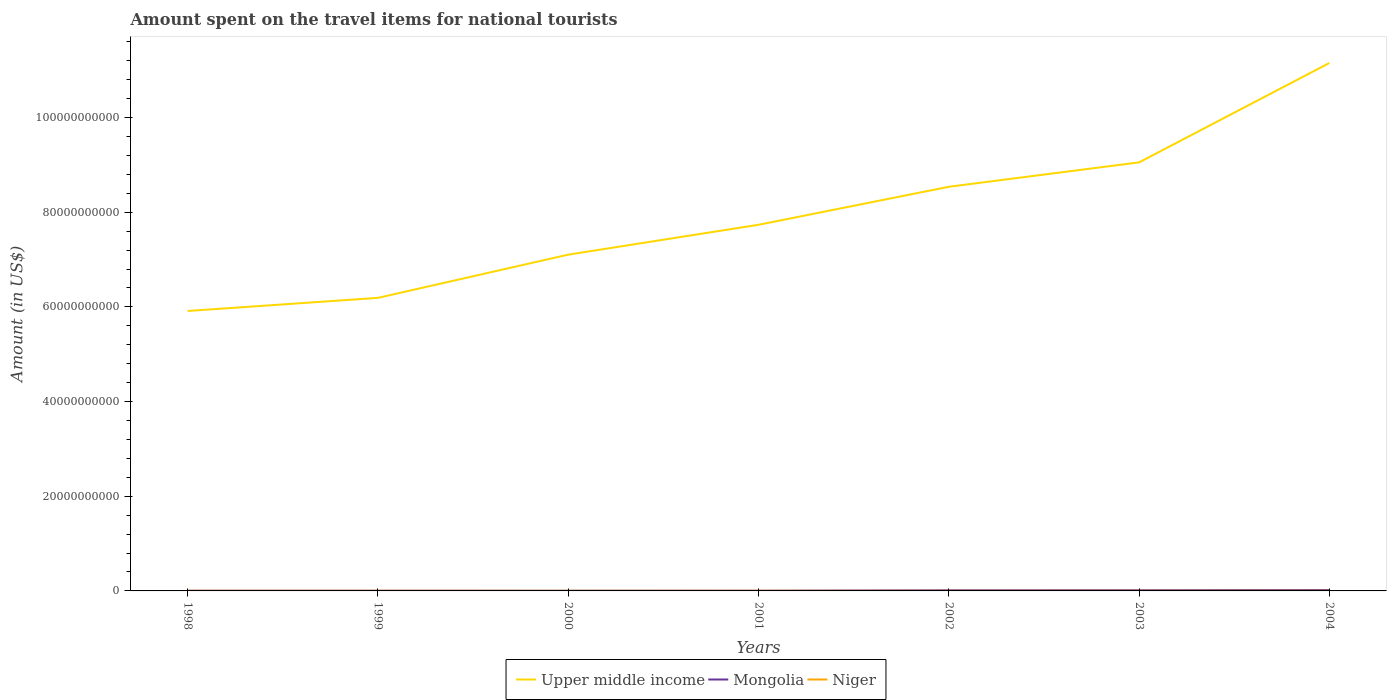How many different coloured lines are there?
Provide a succinct answer. 3. Across all years, what is the maximum amount spent on the travel items for national tourists in Niger?
Ensure brevity in your answer.  2.00e+07. In which year was the amount spent on the travel items for national tourists in Niger maximum?
Keep it short and to the point. 2002. What is the total amount spent on the travel items for national tourists in Mongolia in the graph?
Your response must be concise. -9.50e+07. What is the difference between the highest and the second highest amount spent on the travel items for national tourists in Niger?
Provide a short and direct response. 1.10e+07. Is the amount spent on the travel items for national tourists in Mongolia strictly greater than the amount spent on the travel items for national tourists in Upper middle income over the years?
Your answer should be compact. Yes. What is the difference between two consecutive major ticks on the Y-axis?
Ensure brevity in your answer.  2.00e+1. Does the graph contain grids?
Provide a short and direct response. No. What is the title of the graph?
Offer a terse response. Amount spent on the travel items for national tourists. Does "Ghana" appear as one of the legend labels in the graph?
Make the answer very short. No. What is the Amount (in US$) of Upper middle income in 1998?
Offer a very short reply. 5.91e+1. What is the Amount (in US$) in Mongolia in 1998?
Provide a succinct answer. 3.50e+07. What is the Amount (in US$) in Niger in 1998?
Ensure brevity in your answer.  2.70e+07. What is the Amount (in US$) in Upper middle income in 1999?
Ensure brevity in your answer.  6.19e+1. What is the Amount (in US$) of Mongolia in 1999?
Provide a succinct answer. 3.60e+07. What is the Amount (in US$) of Niger in 1999?
Your answer should be very brief. 2.50e+07. What is the Amount (in US$) of Upper middle income in 2000?
Offer a very short reply. 7.10e+1. What is the Amount (in US$) of Mongolia in 2000?
Give a very brief answer. 3.60e+07. What is the Amount (in US$) of Niger in 2000?
Make the answer very short. 2.30e+07. What is the Amount (in US$) in Upper middle income in 2001?
Give a very brief answer. 7.74e+1. What is the Amount (in US$) of Mongolia in 2001?
Offer a terse response. 3.90e+07. What is the Amount (in US$) in Niger in 2001?
Your response must be concise. 3.00e+07. What is the Amount (in US$) in Upper middle income in 2002?
Ensure brevity in your answer.  8.54e+1. What is the Amount (in US$) of Mongolia in 2002?
Give a very brief answer. 1.30e+08. What is the Amount (in US$) in Upper middle income in 2003?
Offer a very short reply. 9.05e+1. What is the Amount (in US$) in Mongolia in 2003?
Keep it short and to the point. 1.43e+08. What is the Amount (in US$) of Niger in 2003?
Offer a terse response. 2.70e+07. What is the Amount (in US$) in Upper middle income in 2004?
Offer a terse response. 1.12e+11. What is the Amount (in US$) of Mongolia in 2004?
Offer a very short reply. 1.85e+08. What is the Amount (in US$) of Niger in 2004?
Offer a terse response. 3.10e+07. Across all years, what is the maximum Amount (in US$) of Upper middle income?
Your response must be concise. 1.12e+11. Across all years, what is the maximum Amount (in US$) in Mongolia?
Give a very brief answer. 1.85e+08. Across all years, what is the maximum Amount (in US$) in Niger?
Keep it short and to the point. 3.10e+07. Across all years, what is the minimum Amount (in US$) in Upper middle income?
Give a very brief answer. 5.91e+1. Across all years, what is the minimum Amount (in US$) of Mongolia?
Your answer should be very brief. 3.50e+07. What is the total Amount (in US$) of Upper middle income in the graph?
Ensure brevity in your answer.  5.57e+11. What is the total Amount (in US$) of Mongolia in the graph?
Ensure brevity in your answer.  6.04e+08. What is the total Amount (in US$) in Niger in the graph?
Give a very brief answer. 1.83e+08. What is the difference between the Amount (in US$) in Upper middle income in 1998 and that in 1999?
Provide a succinct answer. -2.77e+09. What is the difference between the Amount (in US$) of Mongolia in 1998 and that in 1999?
Provide a short and direct response. -1.00e+06. What is the difference between the Amount (in US$) in Niger in 1998 and that in 1999?
Ensure brevity in your answer.  2.00e+06. What is the difference between the Amount (in US$) in Upper middle income in 1998 and that in 2000?
Offer a very short reply. -1.19e+1. What is the difference between the Amount (in US$) in Mongolia in 1998 and that in 2000?
Your answer should be compact. -1.00e+06. What is the difference between the Amount (in US$) in Niger in 1998 and that in 2000?
Offer a terse response. 4.00e+06. What is the difference between the Amount (in US$) in Upper middle income in 1998 and that in 2001?
Ensure brevity in your answer.  -1.82e+1. What is the difference between the Amount (in US$) of Niger in 1998 and that in 2001?
Ensure brevity in your answer.  -3.00e+06. What is the difference between the Amount (in US$) of Upper middle income in 1998 and that in 2002?
Keep it short and to the point. -2.62e+1. What is the difference between the Amount (in US$) of Mongolia in 1998 and that in 2002?
Offer a terse response. -9.50e+07. What is the difference between the Amount (in US$) of Upper middle income in 1998 and that in 2003?
Keep it short and to the point. -3.14e+1. What is the difference between the Amount (in US$) in Mongolia in 1998 and that in 2003?
Make the answer very short. -1.08e+08. What is the difference between the Amount (in US$) of Upper middle income in 1998 and that in 2004?
Keep it short and to the point. -5.24e+1. What is the difference between the Amount (in US$) in Mongolia in 1998 and that in 2004?
Your answer should be very brief. -1.50e+08. What is the difference between the Amount (in US$) in Niger in 1998 and that in 2004?
Provide a succinct answer. -4.00e+06. What is the difference between the Amount (in US$) in Upper middle income in 1999 and that in 2000?
Provide a short and direct response. -9.13e+09. What is the difference between the Amount (in US$) of Niger in 1999 and that in 2000?
Give a very brief answer. 2.00e+06. What is the difference between the Amount (in US$) of Upper middle income in 1999 and that in 2001?
Offer a very short reply. -1.54e+1. What is the difference between the Amount (in US$) in Niger in 1999 and that in 2001?
Keep it short and to the point. -5.00e+06. What is the difference between the Amount (in US$) in Upper middle income in 1999 and that in 2002?
Make the answer very short. -2.35e+1. What is the difference between the Amount (in US$) of Mongolia in 1999 and that in 2002?
Provide a short and direct response. -9.40e+07. What is the difference between the Amount (in US$) of Niger in 1999 and that in 2002?
Your answer should be very brief. 5.00e+06. What is the difference between the Amount (in US$) of Upper middle income in 1999 and that in 2003?
Offer a very short reply. -2.86e+1. What is the difference between the Amount (in US$) of Mongolia in 1999 and that in 2003?
Give a very brief answer. -1.07e+08. What is the difference between the Amount (in US$) in Upper middle income in 1999 and that in 2004?
Your answer should be compact. -4.96e+1. What is the difference between the Amount (in US$) of Mongolia in 1999 and that in 2004?
Give a very brief answer. -1.49e+08. What is the difference between the Amount (in US$) in Niger in 1999 and that in 2004?
Keep it short and to the point. -6.00e+06. What is the difference between the Amount (in US$) in Upper middle income in 2000 and that in 2001?
Ensure brevity in your answer.  -6.31e+09. What is the difference between the Amount (in US$) in Mongolia in 2000 and that in 2001?
Your answer should be compact. -3.00e+06. What is the difference between the Amount (in US$) of Niger in 2000 and that in 2001?
Offer a very short reply. -7.00e+06. What is the difference between the Amount (in US$) of Upper middle income in 2000 and that in 2002?
Give a very brief answer. -1.43e+1. What is the difference between the Amount (in US$) of Mongolia in 2000 and that in 2002?
Offer a terse response. -9.40e+07. What is the difference between the Amount (in US$) of Upper middle income in 2000 and that in 2003?
Give a very brief answer. -1.95e+1. What is the difference between the Amount (in US$) in Mongolia in 2000 and that in 2003?
Offer a terse response. -1.07e+08. What is the difference between the Amount (in US$) of Niger in 2000 and that in 2003?
Your answer should be compact. -4.00e+06. What is the difference between the Amount (in US$) in Upper middle income in 2000 and that in 2004?
Keep it short and to the point. -4.05e+1. What is the difference between the Amount (in US$) in Mongolia in 2000 and that in 2004?
Your answer should be very brief. -1.49e+08. What is the difference between the Amount (in US$) in Niger in 2000 and that in 2004?
Offer a terse response. -8.00e+06. What is the difference between the Amount (in US$) in Upper middle income in 2001 and that in 2002?
Offer a very short reply. -8.03e+09. What is the difference between the Amount (in US$) in Mongolia in 2001 and that in 2002?
Your response must be concise. -9.10e+07. What is the difference between the Amount (in US$) of Upper middle income in 2001 and that in 2003?
Offer a very short reply. -1.32e+1. What is the difference between the Amount (in US$) in Mongolia in 2001 and that in 2003?
Provide a succinct answer. -1.04e+08. What is the difference between the Amount (in US$) of Niger in 2001 and that in 2003?
Provide a succinct answer. 3.00e+06. What is the difference between the Amount (in US$) of Upper middle income in 2001 and that in 2004?
Ensure brevity in your answer.  -3.42e+1. What is the difference between the Amount (in US$) in Mongolia in 2001 and that in 2004?
Offer a very short reply. -1.46e+08. What is the difference between the Amount (in US$) in Upper middle income in 2002 and that in 2003?
Offer a very short reply. -5.16e+09. What is the difference between the Amount (in US$) in Mongolia in 2002 and that in 2003?
Offer a very short reply. -1.30e+07. What is the difference between the Amount (in US$) in Niger in 2002 and that in 2003?
Offer a terse response. -7.00e+06. What is the difference between the Amount (in US$) in Upper middle income in 2002 and that in 2004?
Provide a succinct answer. -2.62e+1. What is the difference between the Amount (in US$) in Mongolia in 2002 and that in 2004?
Offer a terse response. -5.50e+07. What is the difference between the Amount (in US$) in Niger in 2002 and that in 2004?
Your response must be concise. -1.10e+07. What is the difference between the Amount (in US$) of Upper middle income in 2003 and that in 2004?
Provide a short and direct response. -2.10e+1. What is the difference between the Amount (in US$) in Mongolia in 2003 and that in 2004?
Provide a succinct answer. -4.20e+07. What is the difference between the Amount (in US$) of Niger in 2003 and that in 2004?
Provide a short and direct response. -4.00e+06. What is the difference between the Amount (in US$) in Upper middle income in 1998 and the Amount (in US$) in Mongolia in 1999?
Provide a succinct answer. 5.91e+1. What is the difference between the Amount (in US$) of Upper middle income in 1998 and the Amount (in US$) of Niger in 1999?
Provide a short and direct response. 5.91e+1. What is the difference between the Amount (in US$) in Upper middle income in 1998 and the Amount (in US$) in Mongolia in 2000?
Offer a very short reply. 5.91e+1. What is the difference between the Amount (in US$) in Upper middle income in 1998 and the Amount (in US$) in Niger in 2000?
Give a very brief answer. 5.91e+1. What is the difference between the Amount (in US$) of Upper middle income in 1998 and the Amount (in US$) of Mongolia in 2001?
Give a very brief answer. 5.91e+1. What is the difference between the Amount (in US$) in Upper middle income in 1998 and the Amount (in US$) in Niger in 2001?
Your answer should be very brief. 5.91e+1. What is the difference between the Amount (in US$) of Upper middle income in 1998 and the Amount (in US$) of Mongolia in 2002?
Your response must be concise. 5.90e+1. What is the difference between the Amount (in US$) in Upper middle income in 1998 and the Amount (in US$) in Niger in 2002?
Your answer should be very brief. 5.91e+1. What is the difference between the Amount (in US$) of Mongolia in 1998 and the Amount (in US$) of Niger in 2002?
Your answer should be very brief. 1.50e+07. What is the difference between the Amount (in US$) of Upper middle income in 1998 and the Amount (in US$) of Mongolia in 2003?
Provide a succinct answer. 5.90e+1. What is the difference between the Amount (in US$) of Upper middle income in 1998 and the Amount (in US$) of Niger in 2003?
Give a very brief answer. 5.91e+1. What is the difference between the Amount (in US$) in Mongolia in 1998 and the Amount (in US$) in Niger in 2003?
Provide a succinct answer. 8.00e+06. What is the difference between the Amount (in US$) of Upper middle income in 1998 and the Amount (in US$) of Mongolia in 2004?
Your answer should be compact. 5.90e+1. What is the difference between the Amount (in US$) in Upper middle income in 1998 and the Amount (in US$) in Niger in 2004?
Provide a short and direct response. 5.91e+1. What is the difference between the Amount (in US$) in Mongolia in 1998 and the Amount (in US$) in Niger in 2004?
Provide a short and direct response. 4.00e+06. What is the difference between the Amount (in US$) of Upper middle income in 1999 and the Amount (in US$) of Mongolia in 2000?
Your answer should be compact. 6.19e+1. What is the difference between the Amount (in US$) in Upper middle income in 1999 and the Amount (in US$) in Niger in 2000?
Provide a succinct answer. 6.19e+1. What is the difference between the Amount (in US$) of Mongolia in 1999 and the Amount (in US$) of Niger in 2000?
Your answer should be compact. 1.30e+07. What is the difference between the Amount (in US$) of Upper middle income in 1999 and the Amount (in US$) of Mongolia in 2001?
Provide a succinct answer. 6.19e+1. What is the difference between the Amount (in US$) of Upper middle income in 1999 and the Amount (in US$) of Niger in 2001?
Ensure brevity in your answer.  6.19e+1. What is the difference between the Amount (in US$) in Upper middle income in 1999 and the Amount (in US$) in Mongolia in 2002?
Keep it short and to the point. 6.18e+1. What is the difference between the Amount (in US$) of Upper middle income in 1999 and the Amount (in US$) of Niger in 2002?
Offer a terse response. 6.19e+1. What is the difference between the Amount (in US$) in Mongolia in 1999 and the Amount (in US$) in Niger in 2002?
Offer a very short reply. 1.60e+07. What is the difference between the Amount (in US$) in Upper middle income in 1999 and the Amount (in US$) in Mongolia in 2003?
Ensure brevity in your answer.  6.18e+1. What is the difference between the Amount (in US$) of Upper middle income in 1999 and the Amount (in US$) of Niger in 2003?
Offer a terse response. 6.19e+1. What is the difference between the Amount (in US$) of Mongolia in 1999 and the Amount (in US$) of Niger in 2003?
Give a very brief answer. 9.00e+06. What is the difference between the Amount (in US$) in Upper middle income in 1999 and the Amount (in US$) in Mongolia in 2004?
Make the answer very short. 6.17e+1. What is the difference between the Amount (in US$) of Upper middle income in 1999 and the Amount (in US$) of Niger in 2004?
Offer a terse response. 6.19e+1. What is the difference between the Amount (in US$) of Upper middle income in 2000 and the Amount (in US$) of Mongolia in 2001?
Offer a very short reply. 7.10e+1. What is the difference between the Amount (in US$) of Upper middle income in 2000 and the Amount (in US$) of Niger in 2001?
Keep it short and to the point. 7.10e+1. What is the difference between the Amount (in US$) in Mongolia in 2000 and the Amount (in US$) in Niger in 2001?
Give a very brief answer. 6.00e+06. What is the difference between the Amount (in US$) in Upper middle income in 2000 and the Amount (in US$) in Mongolia in 2002?
Make the answer very short. 7.09e+1. What is the difference between the Amount (in US$) of Upper middle income in 2000 and the Amount (in US$) of Niger in 2002?
Ensure brevity in your answer.  7.10e+1. What is the difference between the Amount (in US$) of Mongolia in 2000 and the Amount (in US$) of Niger in 2002?
Make the answer very short. 1.60e+07. What is the difference between the Amount (in US$) of Upper middle income in 2000 and the Amount (in US$) of Mongolia in 2003?
Your answer should be compact. 7.09e+1. What is the difference between the Amount (in US$) in Upper middle income in 2000 and the Amount (in US$) in Niger in 2003?
Offer a very short reply. 7.10e+1. What is the difference between the Amount (in US$) in Mongolia in 2000 and the Amount (in US$) in Niger in 2003?
Provide a succinct answer. 9.00e+06. What is the difference between the Amount (in US$) of Upper middle income in 2000 and the Amount (in US$) of Mongolia in 2004?
Offer a very short reply. 7.09e+1. What is the difference between the Amount (in US$) in Upper middle income in 2000 and the Amount (in US$) in Niger in 2004?
Make the answer very short. 7.10e+1. What is the difference between the Amount (in US$) in Upper middle income in 2001 and the Amount (in US$) in Mongolia in 2002?
Ensure brevity in your answer.  7.72e+1. What is the difference between the Amount (in US$) in Upper middle income in 2001 and the Amount (in US$) in Niger in 2002?
Give a very brief answer. 7.73e+1. What is the difference between the Amount (in US$) in Mongolia in 2001 and the Amount (in US$) in Niger in 2002?
Offer a terse response. 1.90e+07. What is the difference between the Amount (in US$) of Upper middle income in 2001 and the Amount (in US$) of Mongolia in 2003?
Offer a terse response. 7.72e+1. What is the difference between the Amount (in US$) of Upper middle income in 2001 and the Amount (in US$) of Niger in 2003?
Your answer should be very brief. 7.73e+1. What is the difference between the Amount (in US$) of Upper middle income in 2001 and the Amount (in US$) of Mongolia in 2004?
Keep it short and to the point. 7.72e+1. What is the difference between the Amount (in US$) of Upper middle income in 2001 and the Amount (in US$) of Niger in 2004?
Your response must be concise. 7.73e+1. What is the difference between the Amount (in US$) of Upper middle income in 2002 and the Amount (in US$) of Mongolia in 2003?
Your response must be concise. 8.52e+1. What is the difference between the Amount (in US$) of Upper middle income in 2002 and the Amount (in US$) of Niger in 2003?
Give a very brief answer. 8.54e+1. What is the difference between the Amount (in US$) in Mongolia in 2002 and the Amount (in US$) in Niger in 2003?
Ensure brevity in your answer.  1.03e+08. What is the difference between the Amount (in US$) in Upper middle income in 2002 and the Amount (in US$) in Mongolia in 2004?
Make the answer very short. 8.52e+1. What is the difference between the Amount (in US$) of Upper middle income in 2002 and the Amount (in US$) of Niger in 2004?
Your answer should be very brief. 8.53e+1. What is the difference between the Amount (in US$) of Mongolia in 2002 and the Amount (in US$) of Niger in 2004?
Your response must be concise. 9.90e+07. What is the difference between the Amount (in US$) in Upper middle income in 2003 and the Amount (in US$) in Mongolia in 2004?
Keep it short and to the point. 9.04e+1. What is the difference between the Amount (in US$) in Upper middle income in 2003 and the Amount (in US$) in Niger in 2004?
Give a very brief answer. 9.05e+1. What is the difference between the Amount (in US$) in Mongolia in 2003 and the Amount (in US$) in Niger in 2004?
Keep it short and to the point. 1.12e+08. What is the average Amount (in US$) in Upper middle income per year?
Offer a very short reply. 7.96e+1. What is the average Amount (in US$) in Mongolia per year?
Your response must be concise. 8.63e+07. What is the average Amount (in US$) of Niger per year?
Give a very brief answer. 2.61e+07. In the year 1998, what is the difference between the Amount (in US$) in Upper middle income and Amount (in US$) in Mongolia?
Offer a terse response. 5.91e+1. In the year 1998, what is the difference between the Amount (in US$) of Upper middle income and Amount (in US$) of Niger?
Offer a very short reply. 5.91e+1. In the year 1999, what is the difference between the Amount (in US$) in Upper middle income and Amount (in US$) in Mongolia?
Ensure brevity in your answer.  6.19e+1. In the year 1999, what is the difference between the Amount (in US$) in Upper middle income and Amount (in US$) in Niger?
Offer a very short reply. 6.19e+1. In the year 1999, what is the difference between the Amount (in US$) in Mongolia and Amount (in US$) in Niger?
Provide a short and direct response. 1.10e+07. In the year 2000, what is the difference between the Amount (in US$) in Upper middle income and Amount (in US$) in Mongolia?
Provide a succinct answer. 7.10e+1. In the year 2000, what is the difference between the Amount (in US$) of Upper middle income and Amount (in US$) of Niger?
Provide a succinct answer. 7.10e+1. In the year 2000, what is the difference between the Amount (in US$) of Mongolia and Amount (in US$) of Niger?
Make the answer very short. 1.30e+07. In the year 2001, what is the difference between the Amount (in US$) in Upper middle income and Amount (in US$) in Mongolia?
Your answer should be compact. 7.73e+1. In the year 2001, what is the difference between the Amount (in US$) in Upper middle income and Amount (in US$) in Niger?
Give a very brief answer. 7.73e+1. In the year 2001, what is the difference between the Amount (in US$) of Mongolia and Amount (in US$) of Niger?
Offer a very short reply. 9.00e+06. In the year 2002, what is the difference between the Amount (in US$) of Upper middle income and Amount (in US$) of Mongolia?
Your answer should be compact. 8.52e+1. In the year 2002, what is the difference between the Amount (in US$) in Upper middle income and Amount (in US$) in Niger?
Offer a terse response. 8.54e+1. In the year 2002, what is the difference between the Amount (in US$) in Mongolia and Amount (in US$) in Niger?
Ensure brevity in your answer.  1.10e+08. In the year 2003, what is the difference between the Amount (in US$) in Upper middle income and Amount (in US$) in Mongolia?
Provide a short and direct response. 9.04e+1. In the year 2003, what is the difference between the Amount (in US$) of Upper middle income and Amount (in US$) of Niger?
Offer a terse response. 9.05e+1. In the year 2003, what is the difference between the Amount (in US$) of Mongolia and Amount (in US$) of Niger?
Your answer should be very brief. 1.16e+08. In the year 2004, what is the difference between the Amount (in US$) of Upper middle income and Amount (in US$) of Mongolia?
Your answer should be compact. 1.11e+11. In the year 2004, what is the difference between the Amount (in US$) in Upper middle income and Amount (in US$) in Niger?
Give a very brief answer. 1.12e+11. In the year 2004, what is the difference between the Amount (in US$) in Mongolia and Amount (in US$) in Niger?
Offer a very short reply. 1.54e+08. What is the ratio of the Amount (in US$) of Upper middle income in 1998 to that in 1999?
Make the answer very short. 0.96. What is the ratio of the Amount (in US$) of Mongolia in 1998 to that in 1999?
Offer a terse response. 0.97. What is the ratio of the Amount (in US$) in Upper middle income in 1998 to that in 2000?
Your answer should be very brief. 0.83. What is the ratio of the Amount (in US$) of Mongolia in 1998 to that in 2000?
Make the answer very short. 0.97. What is the ratio of the Amount (in US$) in Niger in 1998 to that in 2000?
Ensure brevity in your answer.  1.17. What is the ratio of the Amount (in US$) in Upper middle income in 1998 to that in 2001?
Keep it short and to the point. 0.76. What is the ratio of the Amount (in US$) in Mongolia in 1998 to that in 2001?
Keep it short and to the point. 0.9. What is the ratio of the Amount (in US$) of Upper middle income in 1998 to that in 2002?
Give a very brief answer. 0.69. What is the ratio of the Amount (in US$) in Mongolia in 1998 to that in 2002?
Ensure brevity in your answer.  0.27. What is the ratio of the Amount (in US$) in Niger in 1998 to that in 2002?
Your answer should be very brief. 1.35. What is the ratio of the Amount (in US$) in Upper middle income in 1998 to that in 2003?
Your answer should be very brief. 0.65. What is the ratio of the Amount (in US$) in Mongolia in 1998 to that in 2003?
Your answer should be very brief. 0.24. What is the ratio of the Amount (in US$) of Upper middle income in 1998 to that in 2004?
Your response must be concise. 0.53. What is the ratio of the Amount (in US$) of Mongolia in 1998 to that in 2004?
Your answer should be compact. 0.19. What is the ratio of the Amount (in US$) of Niger in 1998 to that in 2004?
Make the answer very short. 0.87. What is the ratio of the Amount (in US$) of Upper middle income in 1999 to that in 2000?
Offer a very short reply. 0.87. What is the ratio of the Amount (in US$) of Niger in 1999 to that in 2000?
Provide a short and direct response. 1.09. What is the ratio of the Amount (in US$) of Upper middle income in 1999 to that in 2001?
Your answer should be compact. 0.8. What is the ratio of the Amount (in US$) in Mongolia in 1999 to that in 2001?
Provide a succinct answer. 0.92. What is the ratio of the Amount (in US$) of Niger in 1999 to that in 2001?
Your answer should be compact. 0.83. What is the ratio of the Amount (in US$) of Upper middle income in 1999 to that in 2002?
Your response must be concise. 0.73. What is the ratio of the Amount (in US$) of Mongolia in 1999 to that in 2002?
Make the answer very short. 0.28. What is the ratio of the Amount (in US$) of Niger in 1999 to that in 2002?
Provide a short and direct response. 1.25. What is the ratio of the Amount (in US$) in Upper middle income in 1999 to that in 2003?
Your answer should be very brief. 0.68. What is the ratio of the Amount (in US$) in Mongolia in 1999 to that in 2003?
Make the answer very short. 0.25. What is the ratio of the Amount (in US$) in Niger in 1999 to that in 2003?
Ensure brevity in your answer.  0.93. What is the ratio of the Amount (in US$) in Upper middle income in 1999 to that in 2004?
Offer a very short reply. 0.56. What is the ratio of the Amount (in US$) in Mongolia in 1999 to that in 2004?
Your response must be concise. 0.19. What is the ratio of the Amount (in US$) of Niger in 1999 to that in 2004?
Your answer should be compact. 0.81. What is the ratio of the Amount (in US$) of Upper middle income in 2000 to that in 2001?
Your answer should be very brief. 0.92. What is the ratio of the Amount (in US$) of Niger in 2000 to that in 2001?
Provide a short and direct response. 0.77. What is the ratio of the Amount (in US$) in Upper middle income in 2000 to that in 2002?
Offer a very short reply. 0.83. What is the ratio of the Amount (in US$) of Mongolia in 2000 to that in 2002?
Your answer should be very brief. 0.28. What is the ratio of the Amount (in US$) in Niger in 2000 to that in 2002?
Provide a short and direct response. 1.15. What is the ratio of the Amount (in US$) in Upper middle income in 2000 to that in 2003?
Offer a very short reply. 0.78. What is the ratio of the Amount (in US$) in Mongolia in 2000 to that in 2003?
Make the answer very short. 0.25. What is the ratio of the Amount (in US$) of Niger in 2000 to that in 2003?
Give a very brief answer. 0.85. What is the ratio of the Amount (in US$) in Upper middle income in 2000 to that in 2004?
Give a very brief answer. 0.64. What is the ratio of the Amount (in US$) of Mongolia in 2000 to that in 2004?
Your answer should be compact. 0.19. What is the ratio of the Amount (in US$) in Niger in 2000 to that in 2004?
Your answer should be compact. 0.74. What is the ratio of the Amount (in US$) of Upper middle income in 2001 to that in 2002?
Your answer should be compact. 0.91. What is the ratio of the Amount (in US$) in Mongolia in 2001 to that in 2002?
Keep it short and to the point. 0.3. What is the ratio of the Amount (in US$) of Upper middle income in 2001 to that in 2003?
Your response must be concise. 0.85. What is the ratio of the Amount (in US$) in Mongolia in 2001 to that in 2003?
Make the answer very short. 0.27. What is the ratio of the Amount (in US$) in Upper middle income in 2001 to that in 2004?
Keep it short and to the point. 0.69. What is the ratio of the Amount (in US$) of Mongolia in 2001 to that in 2004?
Give a very brief answer. 0.21. What is the ratio of the Amount (in US$) of Niger in 2001 to that in 2004?
Your answer should be very brief. 0.97. What is the ratio of the Amount (in US$) of Upper middle income in 2002 to that in 2003?
Offer a very short reply. 0.94. What is the ratio of the Amount (in US$) in Mongolia in 2002 to that in 2003?
Your answer should be compact. 0.91. What is the ratio of the Amount (in US$) in Niger in 2002 to that in 2003?
Make the answer very short. 0.74. What is the ratio of the Amount (in US$) of Upper middle income in 2002 to that in 2004?
Offer a very short reply. 0.77. What is the ratio of the Amount (in US$) in Mongolia in 2002 to that in 2004?
Your answer should be very brief. 0.7. What is the ratio of the Amount (in US$) in Niger in 2002 to that in 2004?
Offer a terse response. 0.65. What is the ratio of the Amount (in US$) in Upper middle income in 2003 to that in 2004?
Keep it short and to the point. 0.81. What is the ratio of the Amount (in US$) in Mongolia in 2003 to that in 2004?
Your answer should be very brief. 0.77. What is the ratio of the Amount (in US$) of Niger in 2003 to that in 2004?
Provide a short and direct response. 0.87. What is the difference between the highest and the second highest Amount (in US$) of Upper middle income?
Provide a short and direct response. 2.10e+1. What is the difference between the highest and the second highest Amount (in US$) of Mongolia?
Keep it short and to the point. 4.20e+07. What is the difference between the highest and the lowest Amount (in US$) of Upper middle income?
Offer a very short reply. 5.24e+1. What is the difference between the highest and the lowest Amount (in US$) in Mongolia?
Make the answer very short. 1.50e+08. What is the difference between the highest and the lowest Amount (in US$) of Niger?
Provide a succinct answer. 1.10e+07. 